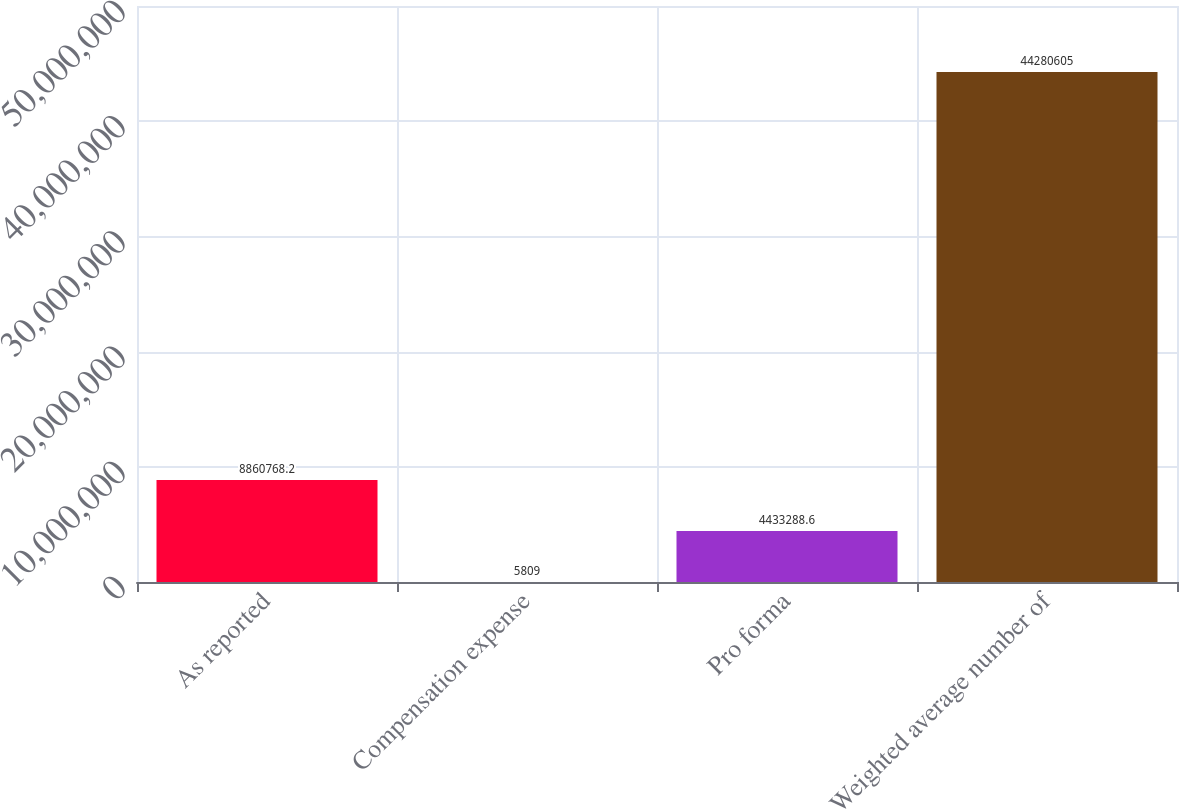Convert chart. <chart><loc_0><loc_0><loc_500><loc_500><bar_chart><fcel>As reported<fcel>Compensation expense<fcel>Pro forma<fcel>Weighted average number of<nl><fcel>8.86077e+06<fcel>5809<fcel>4.43329e+06<fcel>4.42806e+07<nl></chart> 